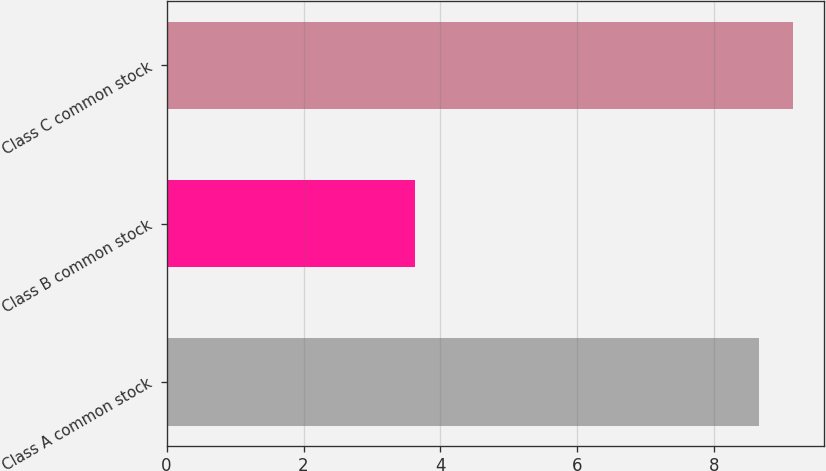Convert chart to OTSL. <chart><loc_0><loc_0><loc_500><loc_500><bar_chart><fcel>Class A common stock<fcel>Class B common stock<fcel>Class C common stock<nl><fcel>8.65<fcel>3.63<fcel>9.15<nl></chart> 